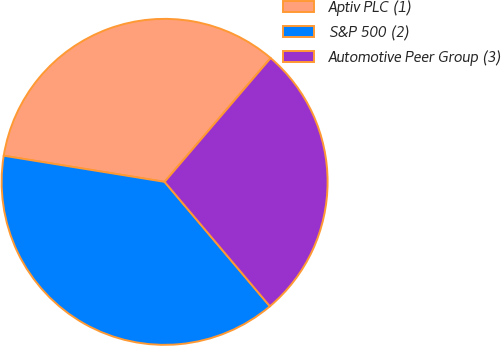Convert chart to OTSL. <chart><loc_0><loc_0><loc_500><loc_500><pie_chart><fcel>Aptiv PLC (1)<fcel>S&P 500 (2)<fcel>Automotive Peer Group (3)<nl><fcel>33.71%<fcel>38.74%<fcel>27.55%<nl></chart> 